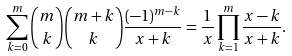<formula> <loc_0><loc_0><loc_500><loc_500>\sum _ { k = 0 } ^ { m } { m \choose k } { m + k \choose k } \frac { ( - 1 ) ^ { m - k } } { x + k } = \frac { 1 } { x } \prod _ { k = 1 } ^ { m } \frac { x - k } { x + k } .</formula> 